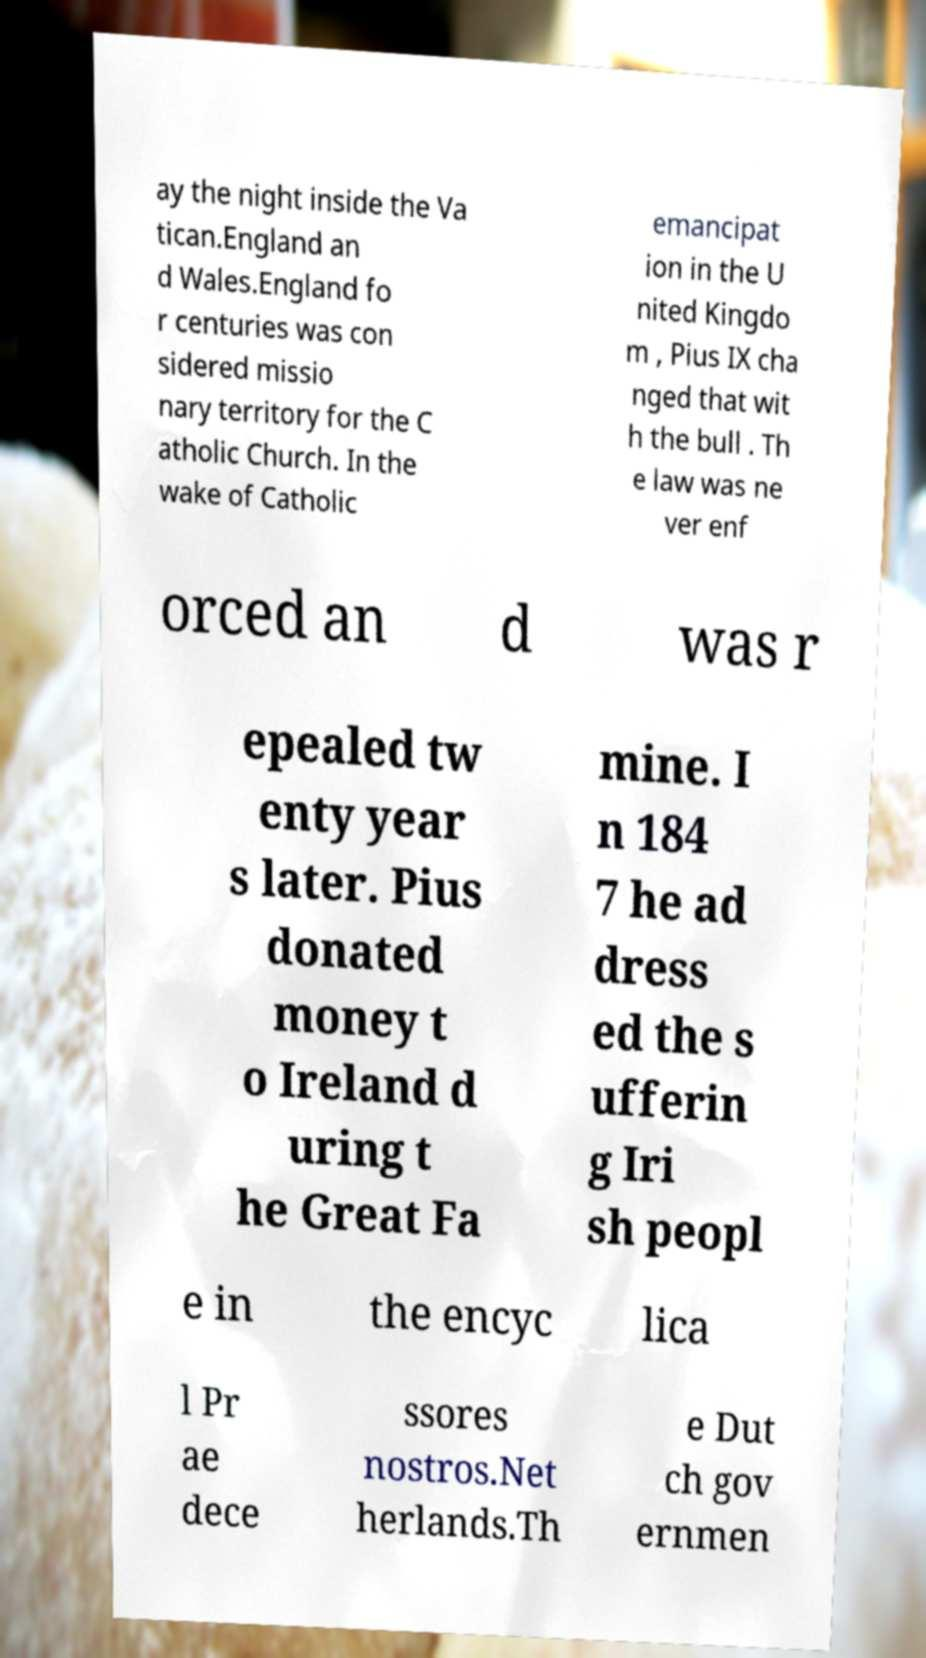There's text embedded in this image that I need extracted. Can you transcribe it verbatim? ay the night inside the Va tican.England an d Wales.England fo r centuries was con sidered missio nary territory for the C atholic Church. In the wake of Catholic emancipat ion in the U nited Kingdo m , Pius IX cha nged that wit h the bull . Th e law was ne ver enf orced an d was r epealed tw enty year s later. Pius donated money t o Ireland d uring t he Great Fa mine. I n 184 7 he ad dress ed the s ufferin g Iri sh peopl e in the encyc lica l Pr ae dece ssores nostros.Net herlands.Th e Dut ch gov ernmen 